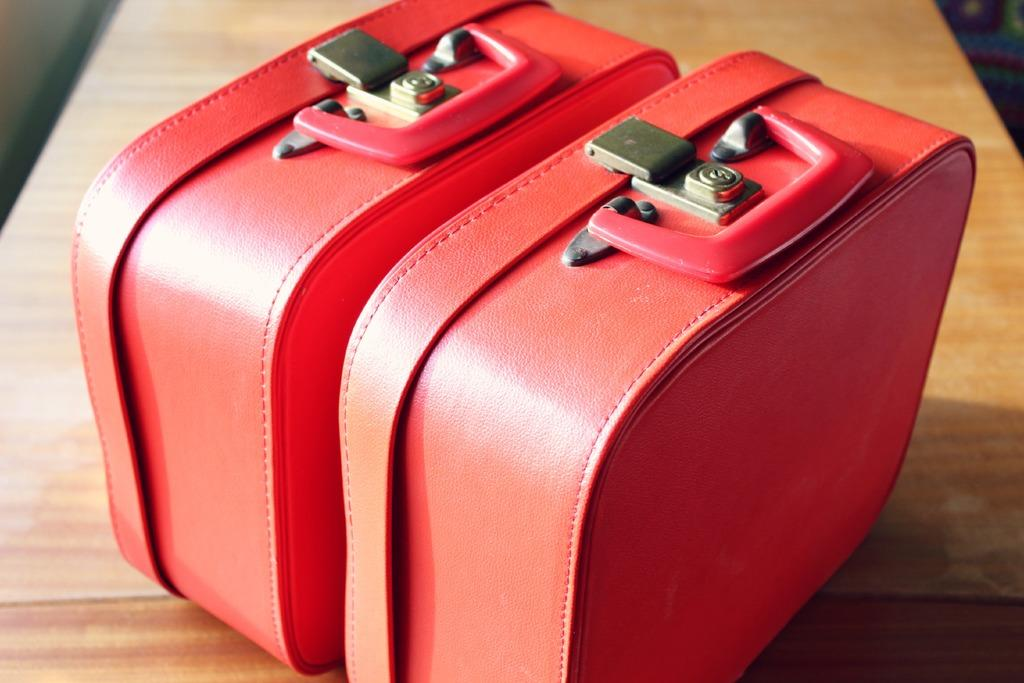What color is the bag that is visible in the image? The bag is red in color. Where is the bag located in the image? The bag is on a table in the image. Where is the toothbrush placed in the image? There is no toothbrush present in the image. What type of salt is visible in the image? There is no salt present in the image. 